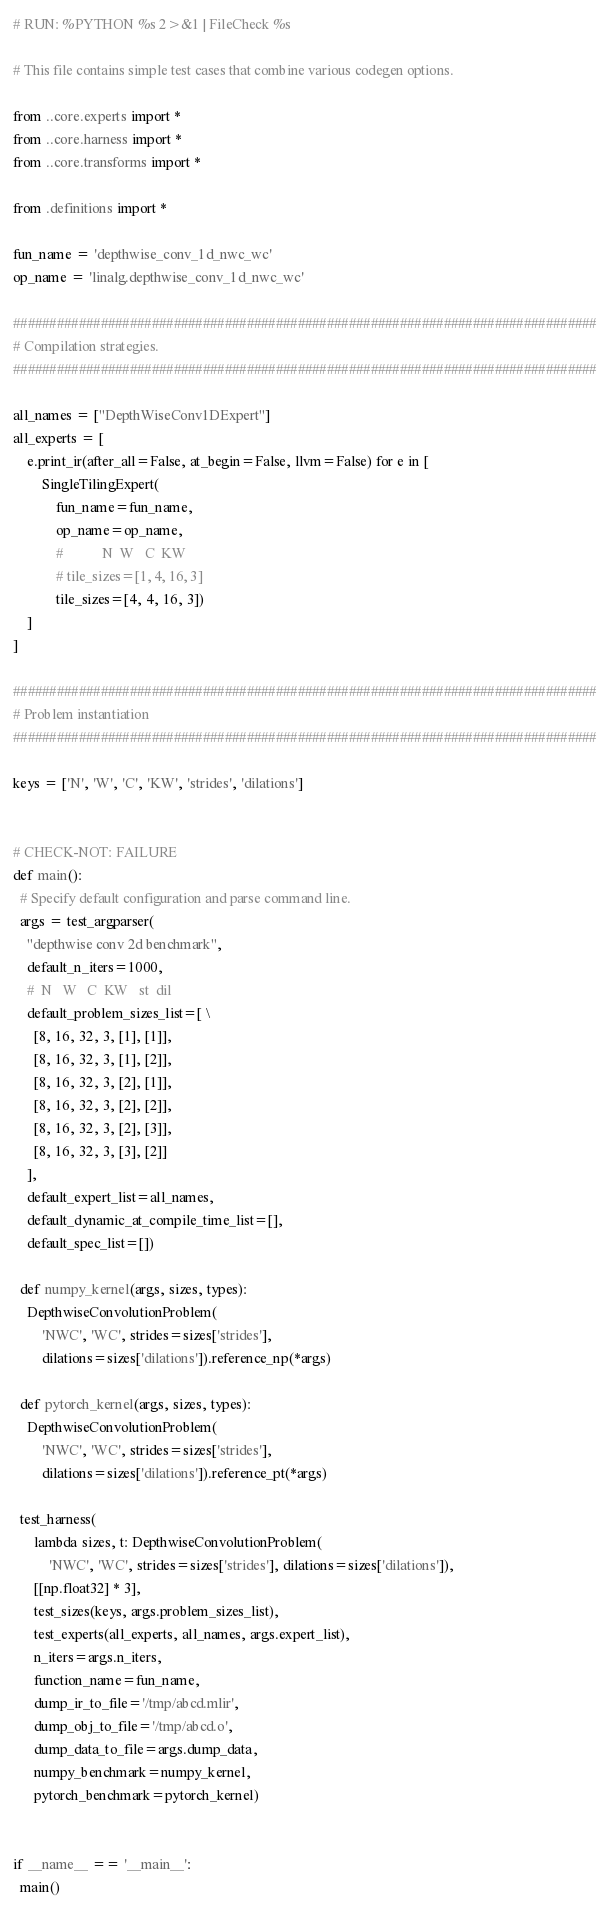<code> <loc_0><loc_0><loc_500><loc_500><_Python_># RUN: %PYTHON %s 2>&1 | FileCheck %s

# This file contains simple test cases that combine various codegen options.

from ..core.experts import *
from ..core.harness import *
from ..core.transforms import *

from .definitions import *

fun_name = 'depthwise_conv_1d_nwc_wc'
op_name = 'linalg.depthwise_conv_1d_nwc_wc'

################################################################################
# Compilation strategies.
################################################################################

all_names = ["DepthWiseConv1DExpert"]
all_experts = [
    e.print_ir(after_all=False, at_begin=False, llvm=False) for e in [
        SingleTilingExpert(
            fun_name=fun_name,
            op_name=op_name,
            #           N  W   C  KW
            # tile_sizes=[1, 4, 16, 3]
            tile_sizes=[4, 4, 16, 3])
    ]
]

################################################################################
# Problem instantiation
################################################################################

keys = ['N', 'W', 'C', 'KW', 'strides', 'dilations']


# CHECK-NOT: FAILURE
def main():
  # Specify default configuration and parse command line.
  args = test_argparser(
    "depthwise conv 2d benchmark",
    default_n_iters=1000,
    #  N   W   C  KW   st  dil
    default_problem_sizes_list=[ \
      [8, 16, 32, 3, [1], [1]],
      [8, 16, 32, 3, [1], [2]],
      [8, 16, 32, 3, [2], [1]],
      [8, 16, 32, 3, [2], [2]],
      [8, 16, 32, 3, [2], [3]],
      [8, 16, 32, 3, [3], [2]]
    ],
    default_expert_list=all_names,
    default_dynamic_at_compile_time_list=[],
    default_spec_list=[])

  def numpy_kernel(args, sizes, types):
    DepthwiseConvolutionProblem(
        'NWC', 'WC', strides=sizes['strides'],
        dilations=sizes['dilations']).reference_np(*args)

  def pytorch_kernel(args, sizes, types):
    DepthwiseConvolutionProblem(
        'NWC', 'WC', strides=sizes['strides'],
        dilations=sizes['dilations']).reference_pt(*args)

  test_harness(
      lambda sizes, t: DepthwiseConvolutionProblem(
          'NWC', 'WC', strides=sizes['strides'], dilations=sizes['dilations']),
      [[np.float32] * 3],
      test_sizes(keys, args.problem_sizes_list),
      test_experts(all_experts, all_names, args.expert_list),
      n_iters=args.n_iters,
      function_name=fun_name,
      dump_ir_to_file='/tmp/abcd.mlir',
      dump_obj_to_file='/tmp/abcd.o',
      dump_data_to_file=args.dump_data,
      numpy_benchmark=numpy_kernel,
      pytorch_benchmark=pytorch_kernel)


if __name__ == '__main__':
  main()
</code> 